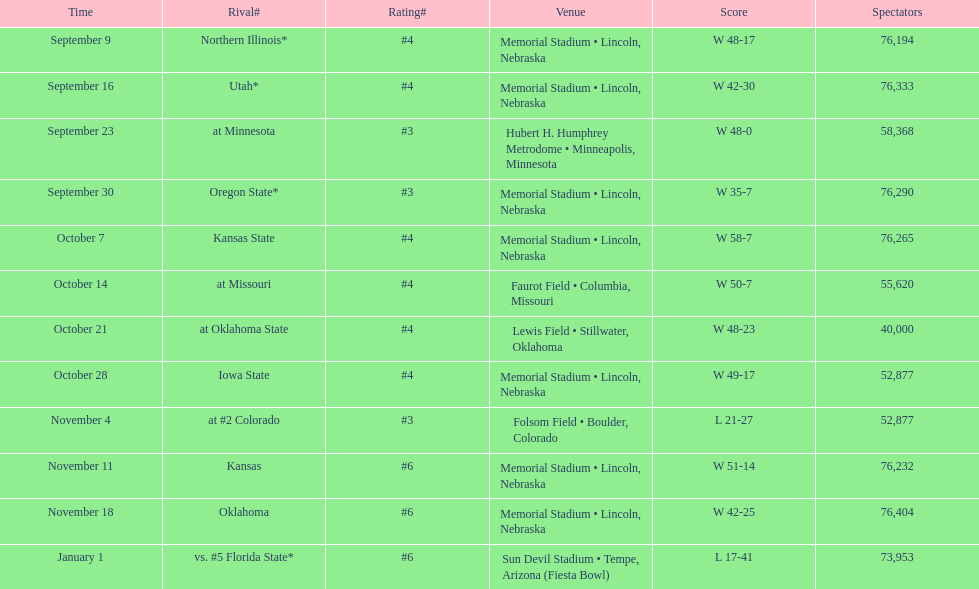Which month is listed the least on this chart? January. 